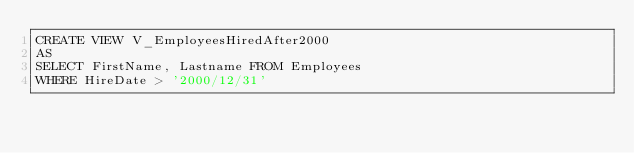Convert code to text. <code><loc_0><loc_0><loc_500><loc_500><_SQL_>CREATE VIEW V_EmployeesHiredAfter2000
AS
SELECT FirstName, Lastname FROM Employees
WHERE HireDate > '2000/12/31'</code> 